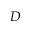Convert formula to latex. <formula><loc_0><loc_0><loc_500><loc_500>D</formula> 